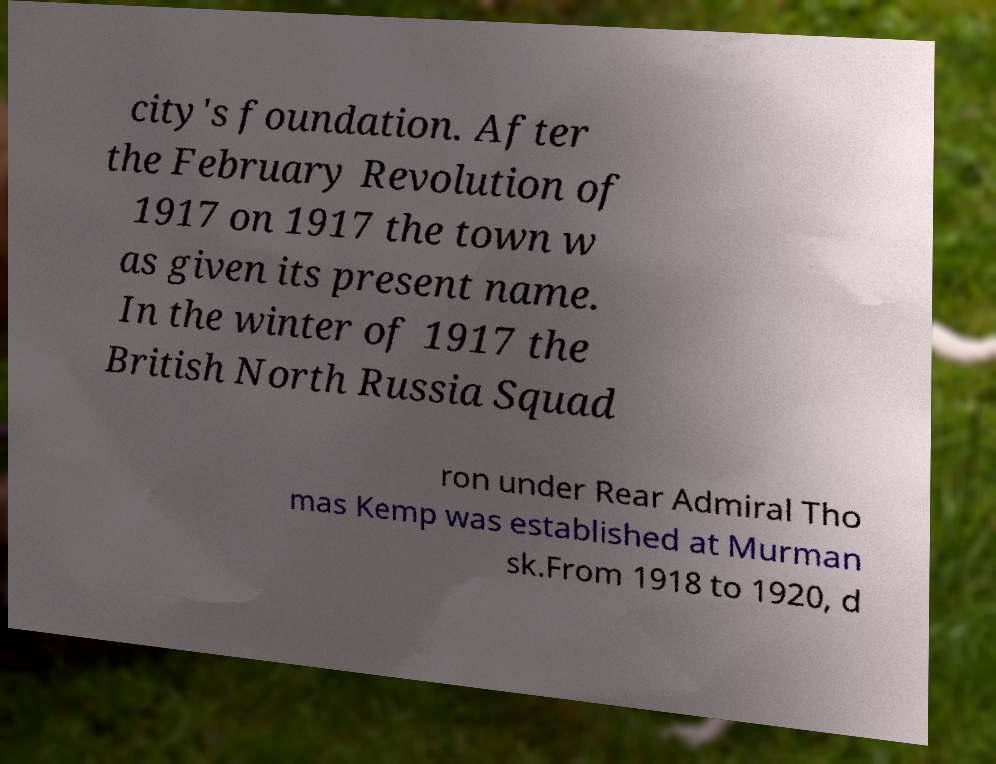What messages or text are displayed in this image? I need them in a readable, typed format. city's foundation. After the February Revolution of 1917 on 1917 the town w as given its present name. In the winter of 1917 the British North Russia Squad ron under Rear Admiral Tho mas Kemp was established at Murman sk.From 1918 to 1920, d 